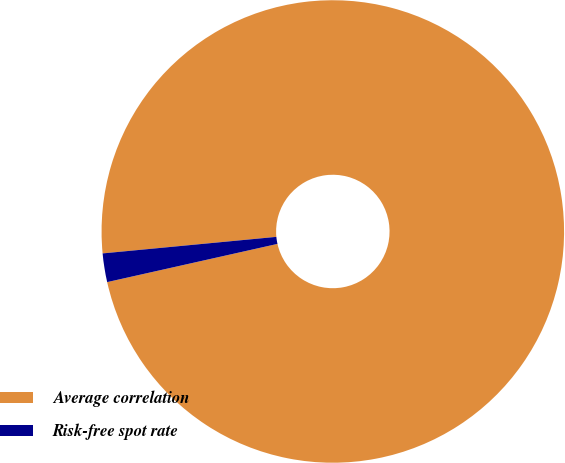Convert chart. <chart><loc_0><loc_0><loc_500><loc_500><pie_chart><fcel>Average correlation<fcel>Risk-free spot rate<nl><fcel>98.0%<fcel>2.0%<nl></chart> 